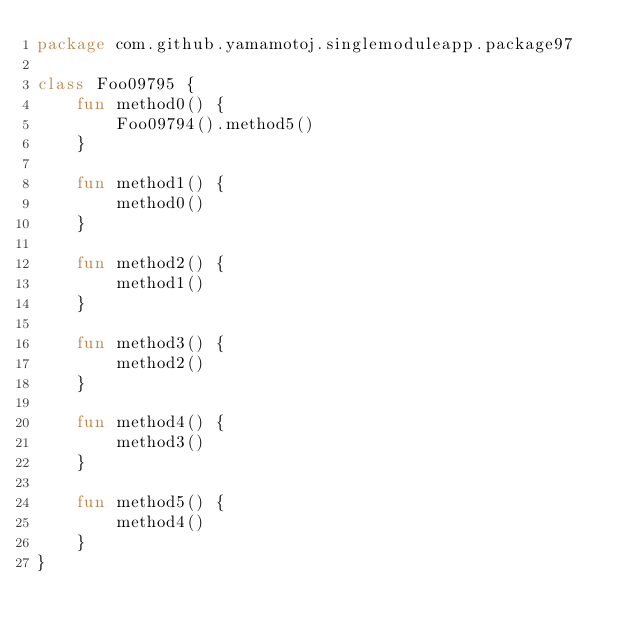<code> <loc_0><loc_0><loc_500><loc_500><_Kotlin_>package com.github.yamamotoj.singlemoduleapp.package97

class Foo09795 {
    fun method0() {
        Foo09794().method5()
    }

    fun method1() {
        method0()
    }

    fun method2() {
        method1()
    }

    fun method3() {
        method2()
    }

    fun method4() {
        method3()
    }

    fun method5() {
        method4()
    }
}
</code> 